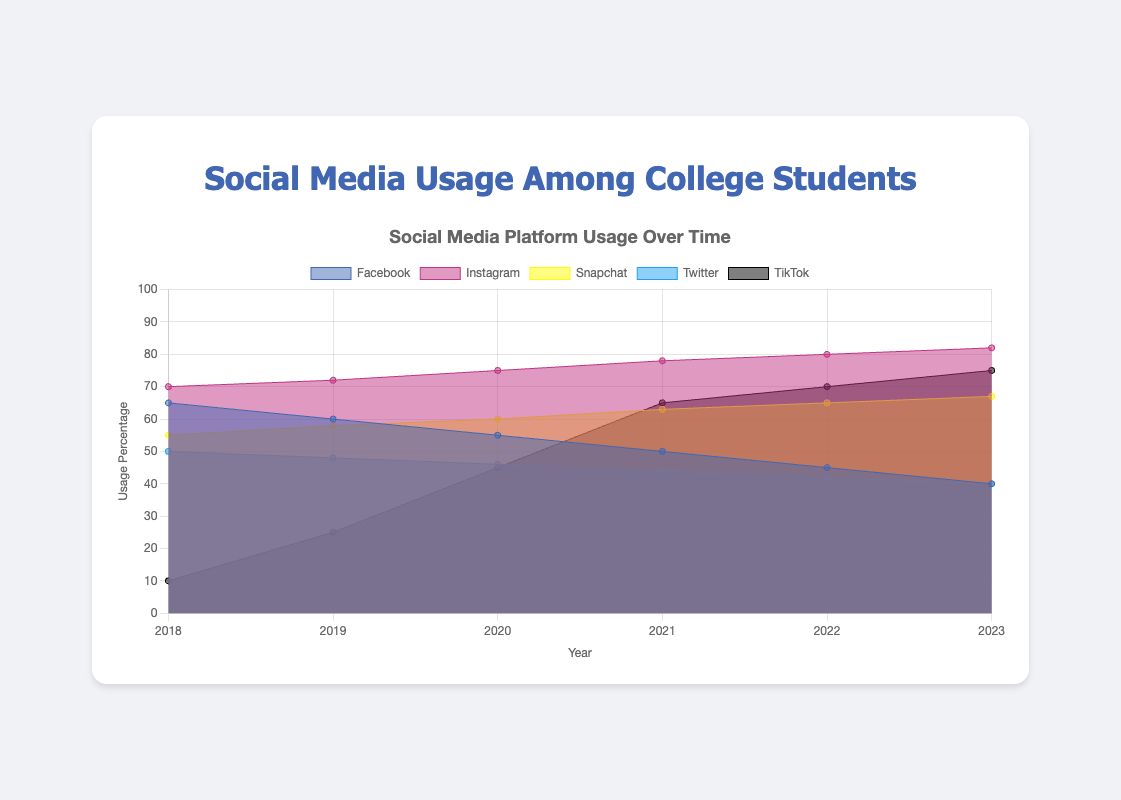what is the title of the figure? The title is displayed at the top of the chart in a larger font size and it reads "Social Media Platform Usage Over Time".
Answer: Social Media Platform Usage Over Time how many social media platforms are represented? The chart legend at the top of the chart lists all the social media platforms: Facebook, Instagram, Snapchat, Twitter, and TikTok.
Answer: 5 what year did TikTok see the largest increase in usage? By looking at the data points for TikTok, the largest increase occurs between 2019 and 2020, where the usage moves from 25% to 45%.
Answer: 2019 to 2020 which platform had the highest usage in 2023? The area chart shows that Instagram had the highest usage in 2023 with 82%.
Answer: Instagram how did Facebook's usage trend over the years? Observing Facebook's line in the area chart, it is clear that usage has been steadily decreasing each year from 65% in 2018 to 40% in 2023.
Answer: Decreasing what was the overall trend in Snapchat's usage from 2018 to 2023? The area chart shows a steady increase in Snapchat's usage, growing from 55% in 2018 to 67% in 2023.
Answer: Increasing in what year did Instagram usage surpass 75%? By examining the year-wise data for Instagram, it can be seen that usage reached 78% in 2021, surpassing 75% for the first time.
Answer: 2021 what is the difference in usage between Instagram and Twitter in 2023? Instagram's usage in 2023 is 82% while Twitter's is 40%, leading to a difference of 82 - 40 = 42%.
Answer: 42% which social media platform showed the fastest growth from 2018 to 2023? By comparing the slopes of the lines for each platform, TikTok shows the fastest growth, increasing from 10% in 2018 to 75% in 2023.
Answer: TikTok did any platform decrease in usage over the years observed? Both Facebook and Twitter show a decreasing trend in their usage over the observed years.
Answer: Yes, Facebook and Twitter 